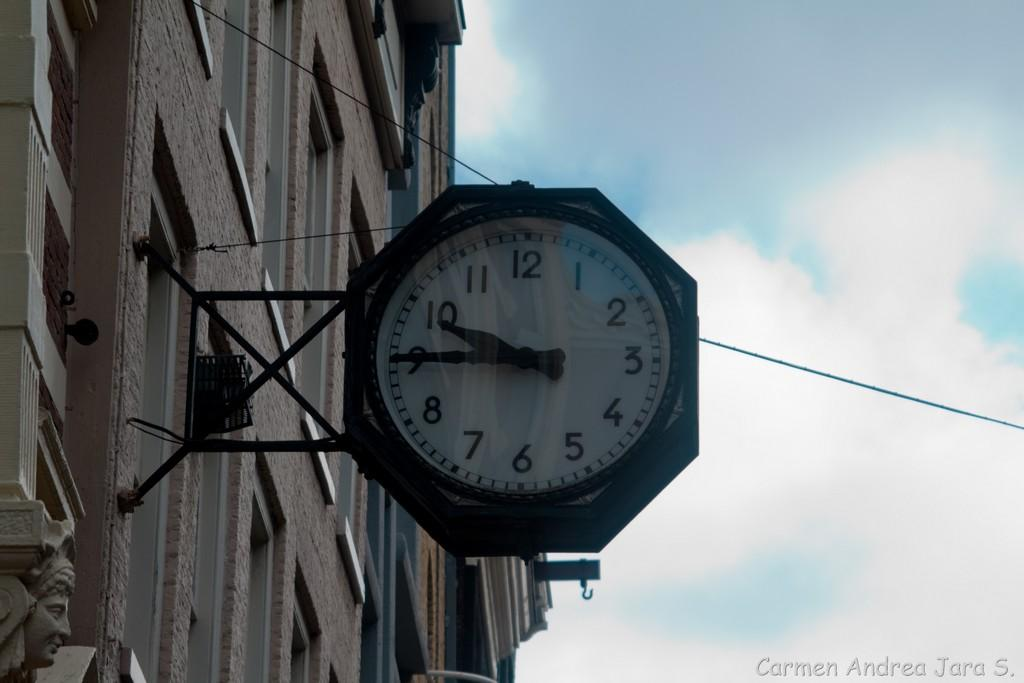Provide a one-sentence caption for the provided image. A clock hanging from a building is showing the time 9:45. 